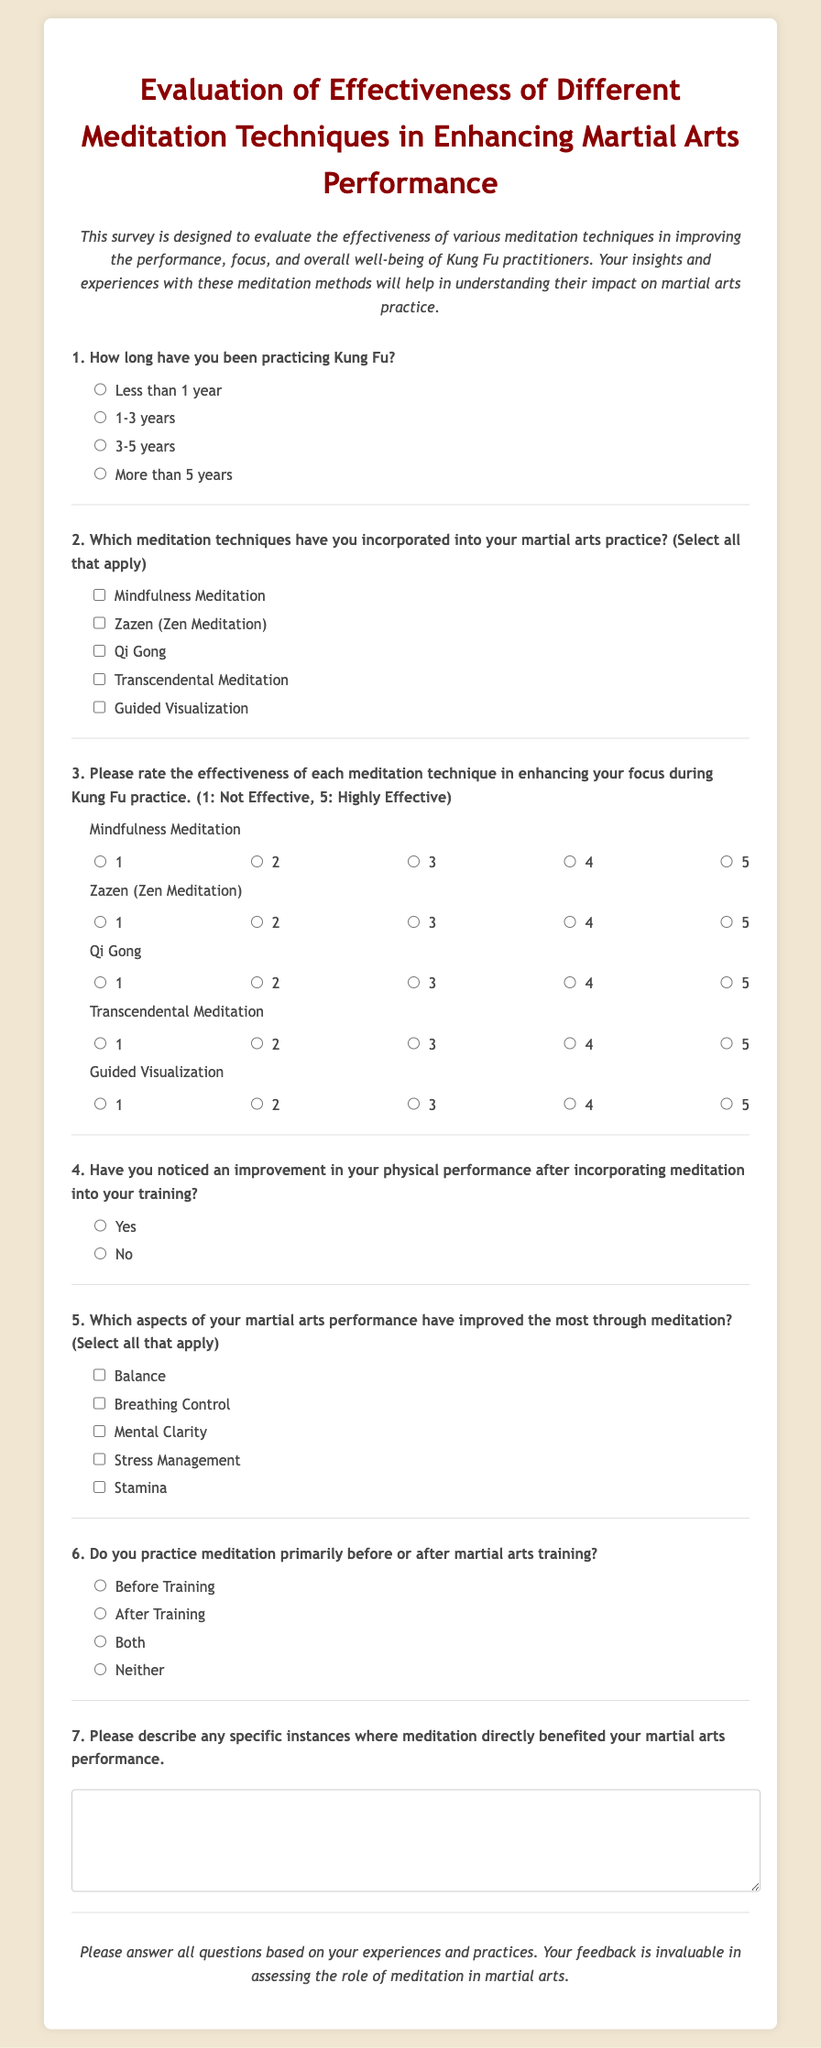What is the title of the survey? The title is stated clearly at the top of the document.
Answer: Evaluation of Effectiveness of Different Meditation Techniques in Enhancing Martial Arts Performance How many meditation techniques are listed for selection? The document contains a section where various meditation techniques are provided to choose from.
Answer: Five Which meditation technique is rated on the highest effectiveness scale? The question about rating effectiveness addresses multiple techniques, where respondents provide ratings from 1 to 5.
Answer: Not determinable from the document, as it depends on individual responses What are the two primary options for when meditation is practiced? The options presented in the survey specify before or after martial arts training.
Answer: Before Training and After Training What is the purpose of the survey? The introductory description summarizes the intention behind collecting responses from participants.
Answer: To evaluate the effectiveness of various meditation techniques in improving performance, focus, and overall well-being of Kung Fu practitioners Which aspect of martial arts performance is included for improvement selection? The survey asks respondents to choose specific aspects related to their performance that may have improved through meditation.
Answer: Balance, Breathing Control, Mental Clarity, Stress Management, Stamina 